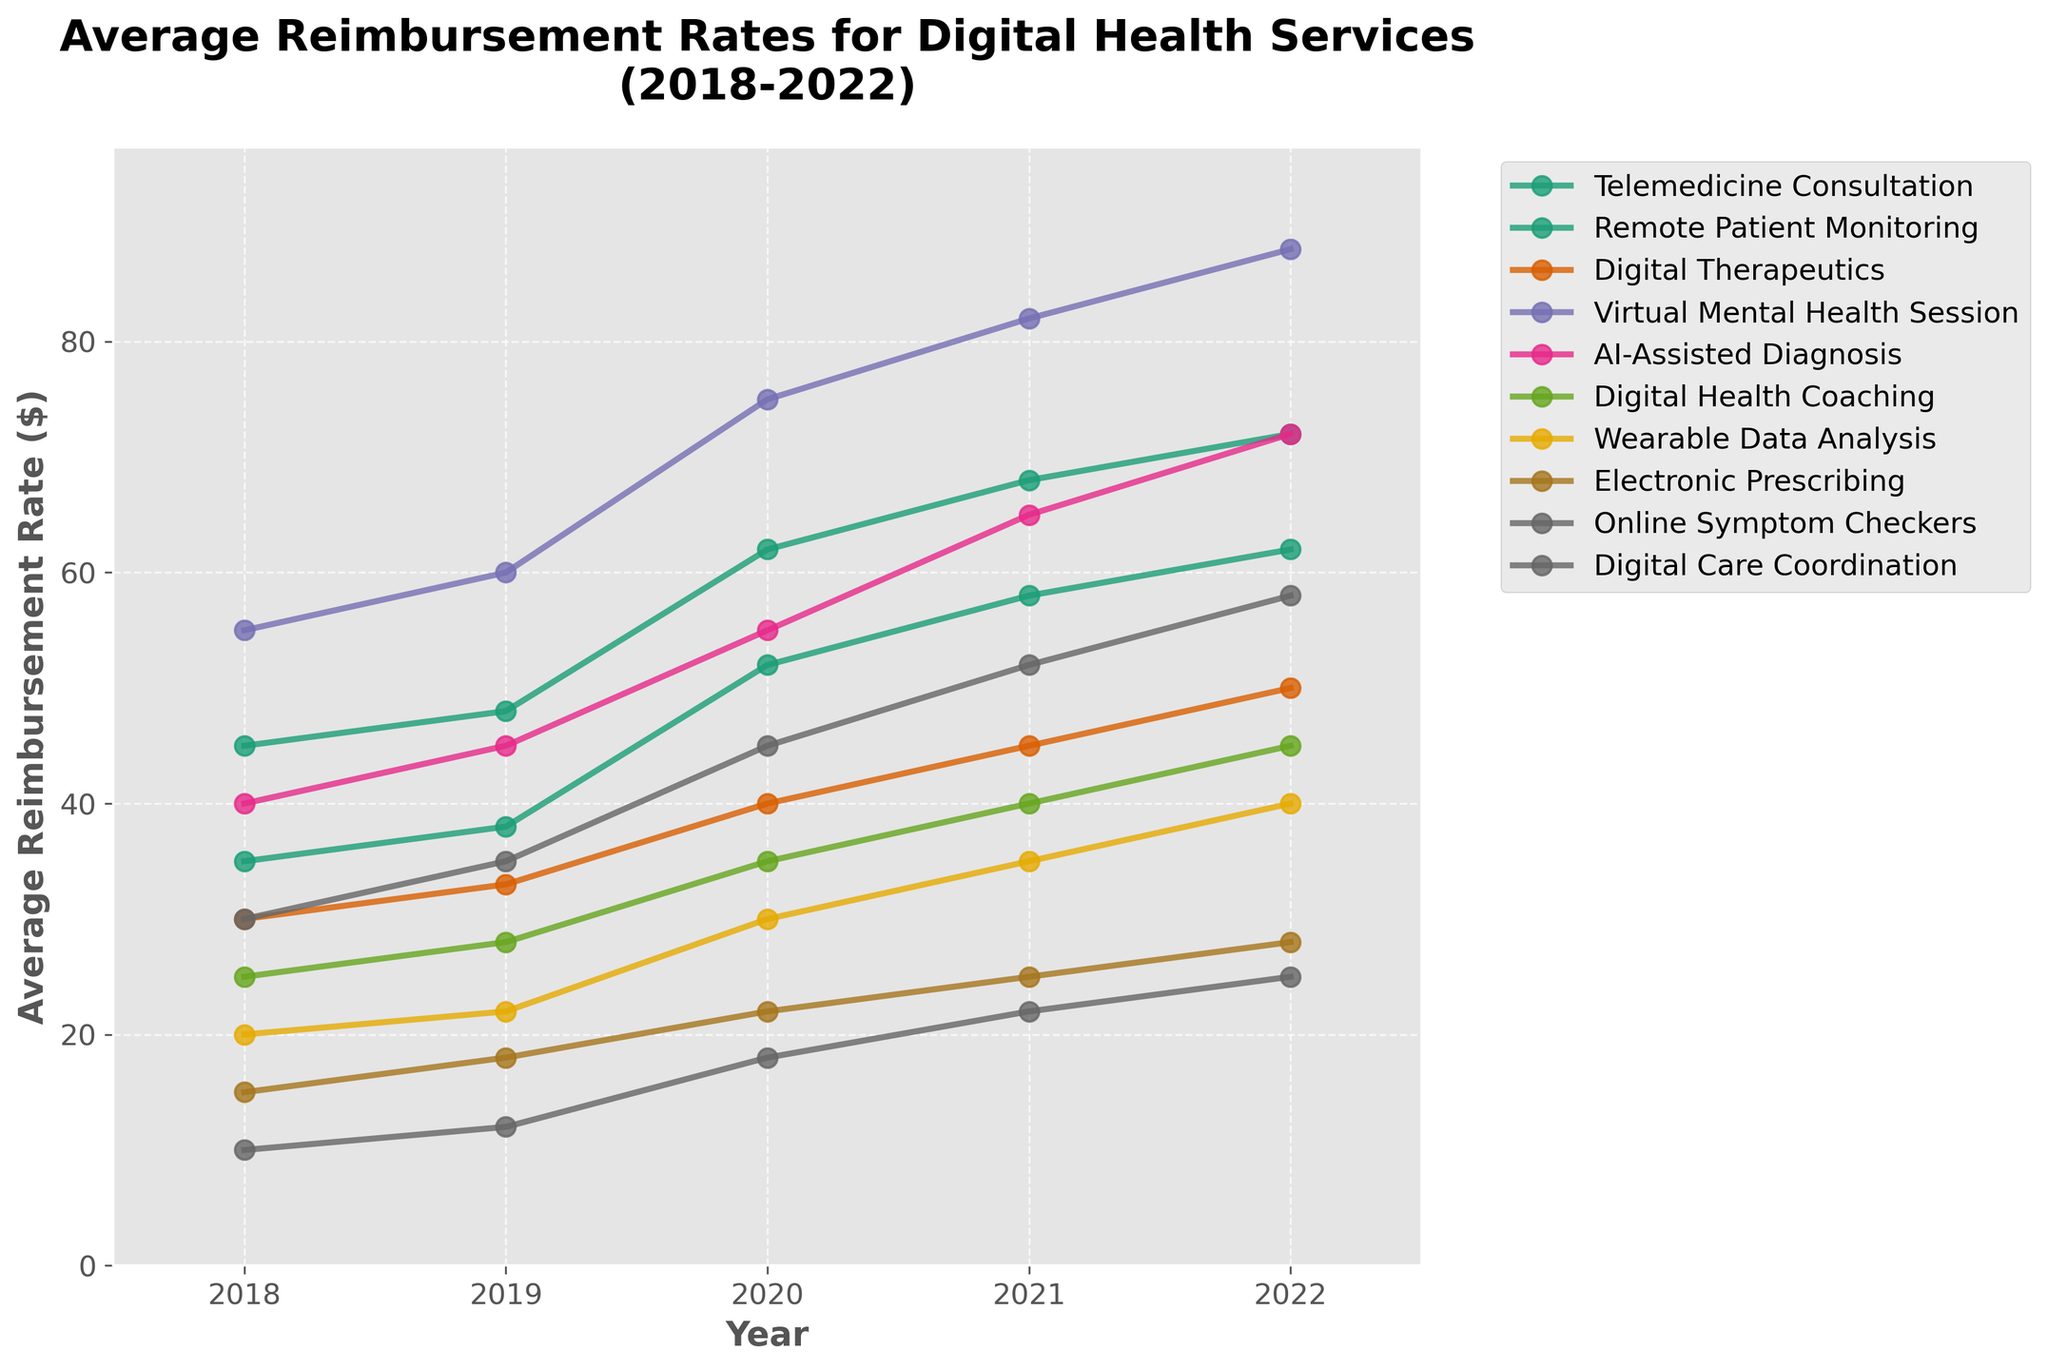What's the highest reimbursement rate reached by any service in the given time period? The highest reimbursement rate can be identified by looking at the peak values in the graph's lines across all services. Virtual Mental Health Session reached $88 in 2022, which is the highest rate.
Answer: $88 Which service showed the most significant increase in reimbursement over the last 5 years? To determine the most significant increase, we need to compare the difference between the 2022 and 2018 reimbursement rates for each service. Virtual Mental Health Session increased from $55 in 2018 to $88 in 2022, a difference of $33, which is the largest increase.
Answer: Virtual Mental Health Session How does the reimbursement rate for Digital Health Coaching in 2022 compare to Remote Patient Monitoring in 2020? The reimbursement rate for Digital Health Coaching in 2022 is $45, while the reimbursement rate for Remote Patient Monitoring in 2020 is $52. Therefore, Remote Patient Monitoring in 2020 has a higher rate.
Answer: Remote Patient Monitoring in 2020 is higher What is the average reimbursement rate for AI-Assisted Diagnosis across all 5 years? To find the average, calculate the sum of AI-Assisted Diagnosis rates from 2018 to 2022 and divide by the number of years. The rates are $40, $45, $55, $65, and $72, summing to $277. Dividing by 5 gives $55.4.
Answer: $55.4 Which two services had identical reimbursement rates in any given year? By visually inspecting the plot, we see that Remote Patient Monitoring and Digital Care Coordination both had a reimbursement rate of $58 in 2022.
Answer: Remote Patient Monitoring and Digital Care Coordination in 2022 What was the combined total reimbursement rate for Telemedicine Consultation and Virtual Mental Health Session in 2021? The reimbursement rate for Telemedicine Consultation in 2021 is $68, and for Virtual Mental Health Session, it is $82. Adding them gives $68 + $82 = $150.
Answer: $150 Which service has the least variability in its reimbursement rates over the years? By examining the plot, Digital Health Coaching shows a consistent upward trend with relatively small differences in its yearly rates compared to other services.
Answer: Digital Health Coaching In which year did Online Symptom Checkers experience the highest growth in reimbursement rate compared to the previous year? To determine the year of highest growth, calculate the differences year-on-year for Online Symptom Checkers. The highest growth occurs between 2019 ($12) and 2020 ($18), a difference of $6.
Answer: 2020 Which services had a lower reimbursement rate in 2021 than Telemedicine Consultation did in 2019? From the graph, Telemedicine Consultation had a rate of $48 in 2019. In 2021, services below $48 include Electronic Prescribing ($25), Online Symptom Checkers ($22), and Wearable Data Analysis ($35).
Answer: Electronic Prescribing, Online Symptom Checkers, Wearable Data Analysis What percentage increase did Digital Therapeutics experience from 2018 to 2022? The 2018 reimbursement rate is $30, and the 2022 rate is $50. The increase is $50 - $30 = $20. The percentage increase is calculated as ($20 / $30) * 100 = 66.67%.
Answer: 66.67% 